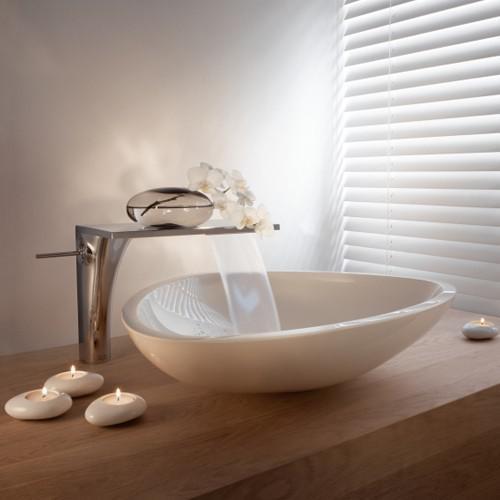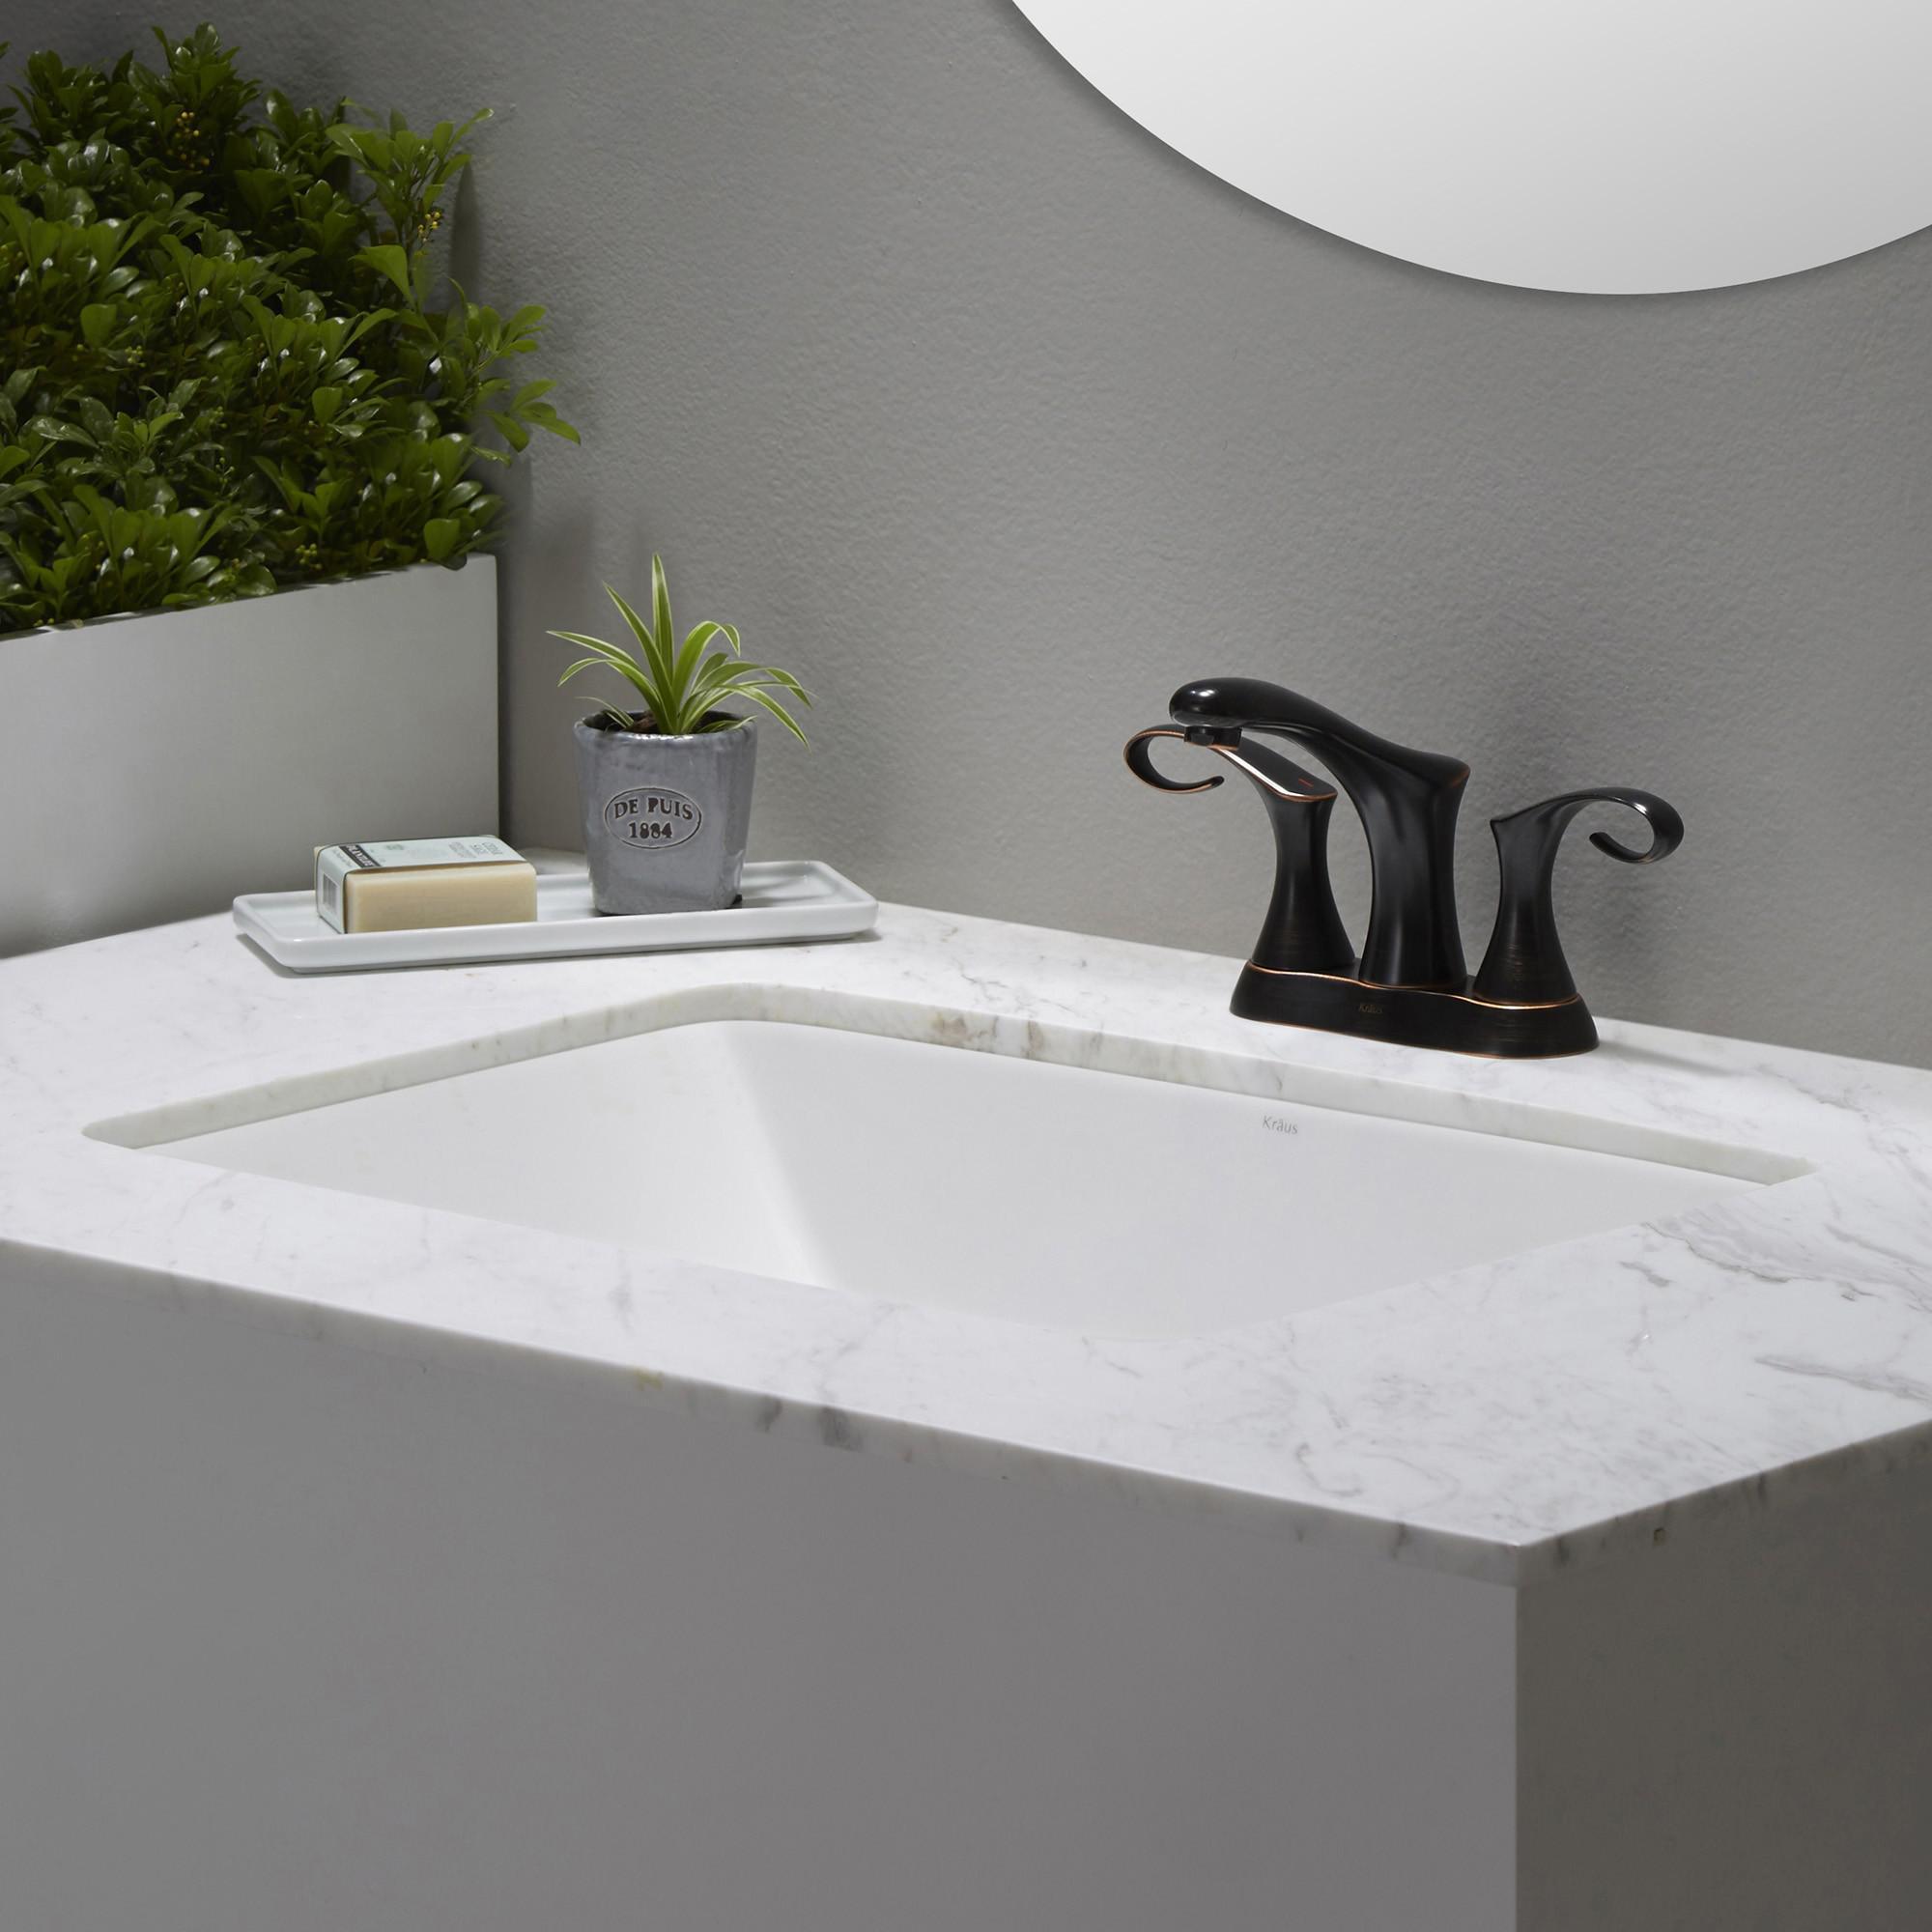The first image is the image on the left, the second image is the image on the right. Evaluate the accuracy of this statement regarding the images: "One image shows a single sink and the other shows two adjacent sinks.". Is it true? Answer yes or no. No. The first image is the image on the left, the second image is the image on the right. Examine the images to the left and right. Is the description "One image shows a single rectangular sink inset in a long white counter, and the other image features two white horizontal elements." accurate? Answer yes or no. No. 